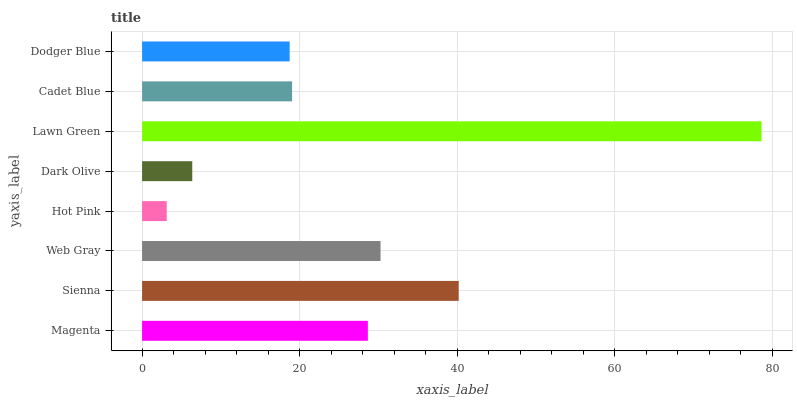Is Hot Pink the minimum?
Answer yes or no. Yes. Is Lawn Green the maximum?
Answer yes or no. Yes. Is Sienna the minimum?
Answer yes or no. No. Is Sienna the maximum?
Answer yes or no. No. Is Sienna greater than Magenta?
Answer yes or no. Yes. Is Magenta less than Sienna?
Answer yes or no. Yes. Is Magenta greater than Sienna?
Answer yes or no. No. Is Sienna less than Magenta?
Answer yes or no. No. Is Magenta the high median?
Answer yes or no. Yes. Is Cadet Blue the low median?
Answer yes or no. Yes. Is Cadet Blue the high median?
Answer yes or no. No. Is Magenta the low median?
Answer yes or no. No. 